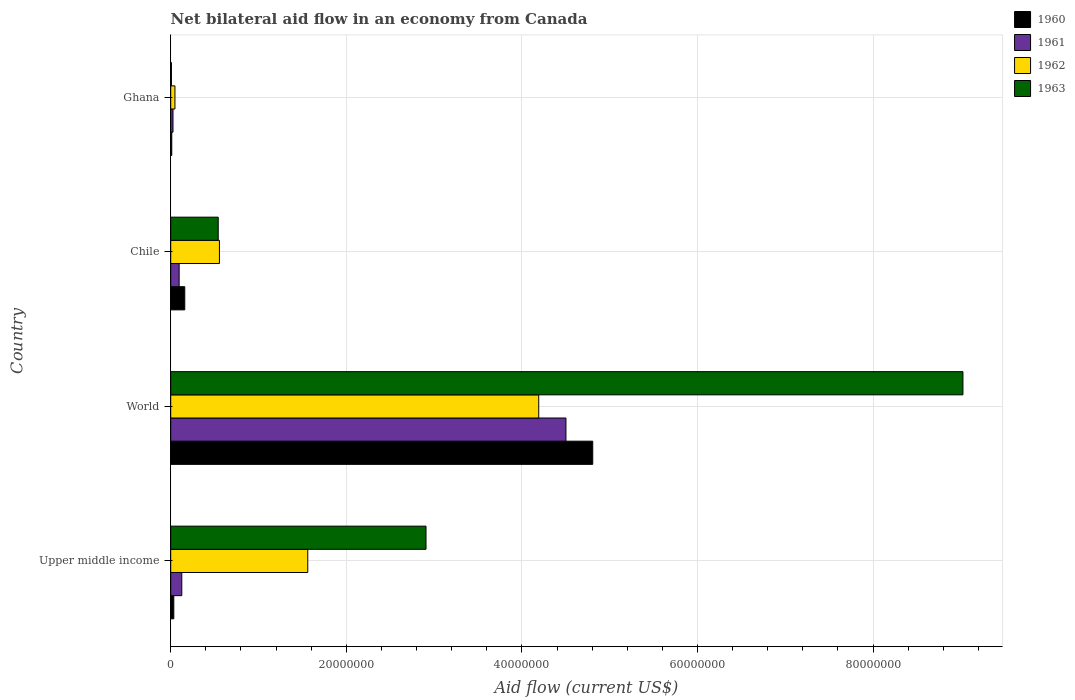How many groups of bars are there?
Provide a short and direct response. 4. How many bars are there on the 2nd tick from the top?
Your answer should be very brief. 4. What is the net bilateral aid flow in 1961 in Upper middle income?
Ensure brevity in your answer.  1.26e+06. Across all countries, what is the maximum net bilateral aid flow in 1961?
Give a very brief answer. 4.50e+07. Across all countries, what is the minimum net bilateral aid flow in 1962?
Offer a very short reply. 4.80e+05. In which country was the net bilateral aid flow in 1962 maximum?
Your response must be concise. World. What is the total net bilateral aid flow in 1962 in the graph?
Keep it short and to the point. 6.36e+07. What is the difference between the net bilateral aid flow in 1960 in Ghana and that in World?
Your answer should be very brief. -4.80e+07. What is the difference between the net bilateral aid flow in 1961 in Chile and the net bilateral aid flow in 1960 in World?
Provide a short and direct response. -4.71e+07. What is the average net bilateral aid flow in 1963 per country?
Ensure brevity in your answer.  3.12e+07. What is the difference between the net bilateral aid flow in 1963 and net bilateral aid flow in 1960 in Upper middle income?
Offer a terse response. 2.87e+07. In how many countries, is the net bilateral aid flow in 1962 greater than 80000000 US$?
Make the answer very short. 0. What is the ratio of the net bilateral aid flow in 1961 in Ghana to that in World?
Give a very brief answer. 0.01. Is the difference between the net bilateral aid flow in 1963 in Ghana and World greater than the difference between the net bilateral aid flow in 1960 in Ghana and World?
Provide a short and direct response. No. What is the difference between the highest and the second highest net bilateral aid flow in 1960?
Offer a terse response. 4.65e+07. What is the difference between the highest and the lowest net bilateral aid flow in 1960?
Keep it short and to the point. 4.80e+07. In how many countries, is the net bilateral aid flow in 1960 greater than the average net bilateral aid flow in 1960 taken over all countries?
Provide a succinct answer. 1. Is it the case that in every country, the sum of the net bilateral aid flow in 1962 and net bilateral aid flow in 1960 is greater than the sum of net bilateral aid flow in 1961 and net bilateral aid flow in 1963?
Provide a short and direct response. No. What does the 2nd bar from the bottom in Chile represents?
Keep it short and to the point. 1961. How many bars are there?
Provide a short and direct response. 16. Are all the bars in the graph horizontal?
Keep it short and to the point. Yes. How many countries are there in the graph?
Your answer should be compact. 4. Are the values on the major ticks of X-axis written in scientific E-notation?
Provide a succinct answer. No. Does the graph contain grids?
Offer a very short reply. Yes. Where does the legend appear in the graph?
Offer a very short reply. Top right. How are the legend labels stacked?
Your answer should be compact. Vertical. What is the title of the graph?
Provide a short and direct response. Net bilateral aid flow in an economy from Canada. Does "1987" appear as one of the legend labels in the graph?
Provide a succinct answer. No. What is the label or title of the X-axis?
Offer a very short reply. Aid flow (current US$). What is the label or title of the Y-axis?
Offer a terse response. Country. What is the Aid flow (current US$) in 1961 in Upper middle income?
Your response must be concise. 1.26e+06. What is the Aid flow (current US$) in 1962 in Upper middle income?
Make the answer very short. 1.56e+07. What is the Aid flow (current US$) of 1963 in Upper middle income?
Provide a succinct answer. 2.91e+07. What is the Aid flow (current US$) of 1960 in World?
Your answer should be compact. 4.81e+07. What is the Aid flow (current US$) of 1961 in World?
Give a very brief answer. 4.50e+07. What is the Aid flow (current US$) of 1962 in World?
Provide a short and direct response. 4.19e+07. What is the Aid flow (current US$) of 1963 in World?
Provide a succinct answer. 9.02e+07. What is the Aid flow (current US$) of 1960 in Chile?
Give a very brief answer. 1.60e+06. What is the Aid flow (current US$) of 1961 in Chile?
Offer a terse response. 9.60e+05. What is the Aid flow (current US$) of 1962 in Chile?
Offer a terse response. 5.55e+06. What is the Aid flow (current US$) of 1963 in Chile?
Offer a very short reply. 5.41e+06. What is the Aid flow (current US$) of 1962 in Ghana?
Make the answer very short. 4.80e+05. What is the Aid flow (current US$) of 1963 in Ghana?
Give a very brief answer. 8.00e+04. Across all countries, what is the maximum Aid flow (current US$) of 1960?
Your answer should be very brief. 4.81e+07. Across all countries, what is the maximum Aid flow (current US$) of 1961?
Offer a very short reply. 4.50e+07. Across all countries, what is the maximum Aid flow (current US$) in 1962?
Your response must be concise. 4.19e+07. Across all countries, what is the maximum Aid flow (current US$) in 1963?
Your response must be concise. 9.02e+07. Across all countries, what is the minimum Aid flow (current US$) of 1961?
Your answer should be very brief. 2.60e+05. Across all countries, what is the minimum Aid flow (current US$) in 1962?
Give a very brief answer. 4.80e+05. Across all countries, what is the minimum Aid flow (current US$) of 1963?
Make the answer very short. 8.00e+04. What is the total Aid flow (current US$) of 1960 in the graph?
Make the answer very short. 5.01e+07. What is the total Aid flow (current US$) of 1961 in the graph?
Keep it short and to the point. 4.75e+07. What is the total Aid flow (current US$) of 1962 in the graph?
Your answer should be very brief. 6.36e+07. What is the total Aid flow (current US$) of 1963 in the graph?
Offer a terse response. 1.25e+08. What is the difference between the Aid flow (current US$) of 1960 in Upper middle income and that in World?
Your answer should be compact. -4.77e+07. What is the difference between the Aid flow (current US$) of 1961 in Upper middle income and that in World?
Your answer should be very brief. -4.38e+07. What is the difference between the Aid flow (current US$) in 1962 in Upper middle income and that in World?
Ensure brevity in your answer.  -2.63e+07. What is the difference between the Aid flow (current US$) in 1963 in Upper middle income and that in World?
Make the answer very short. -6.12e+07. What is the difference between the Aid flow (current US$) in 1960 in Upper middle income and that in Chile?
Your answer should be compact. -1.25e+06. What is the difference between the Aid flow (current US$) of 1961 in Upper middle income and that in Chile?
Provide a succinct answer. 3.00e+05. What is the difference between the Aid flow (current US$) of 1962 in Upper middle income and that in Chile?
Ensure brevity in your answer.  1.01e+07. What is the difference between the Aid flow (current US$) in 1963 in Upper middle income and that in Chile?
Your answer should be compact. 2.37e+07. What is the difference between the Aid flow (current US$) in 1960 in Upper middle income and that in Ghana?
Offer a terse response. 2.30e+05. What is the difference between the Aid flow (current US$) of 1962 in Upper middle income and that in Ghana?
Keep it short and to the point. 1.51e+07. What is the difference between the Aid flow (current US$) in 1963 in Upper middle income and that in Ghana?
Make the answer very short. 2.90e+07. What is the difference between the Aid flow (current US$) in 1960 in World and that in Chile?
Your answer should be very brief. 4.65e+07. What is the difference between the Aid flow (current US$) in 1961 in World and that in Chile?
Keep it short and to the point. 4.41e+07. What is the difference between the Aid flow (current US$) in 1962 in World and that in Chile?
Keep it short and to the point. 3.64e+07. What is the difference between the Aid flow (current US$) of 1963 in World and that in Chile?
Offer a very short reply. 8.48e+07. What is the difference between the Aid flow (current US$) of 1960 in World and that in Ghana?
Keep it short and to the point. 4.80e+07. What is the difference between the Aid flow (current US$) in 1961 in World and that in Ghana?
Keep it short and to the point. 4.48e+07. What is the difference between the Aid flow (current US$) in 1962 in World and that in Ghana?
Keep it short and to the point. 4.14e+07. What is the difference between the Aid flow (current US$) of 1963 in World and that in Ghana?
Give a very brief answer. 9.02e+07. What is the difference between the Aid flow (current US$) in 1960 in Chile and that in Ghana?
Your answer should be very brief. 1.48e+06. What is the difference between the Aid flow (current US$) in 1962 in Chile and that in Ghana?
Your response must be concise. 5.07e+06. What is the difference between the Aid flow (current US$) in 1963 in Chile and that in Ghana?
Provide a short and direct response. 5.33e+06. What is the difference between the Aid flow (current US$) of 1960 in Upper middle income and the Aid flow (current US$) of 1961 in World?
Provide a short and direct response. -4.47e+07. What is the difference between the Aid flow (current US$) in 1960 in Upper middle income and the Aid flow (current US$) in 1962 in World?
Your answer should be compact. -4.16e+07. What is the difference between the Aid flow (current US$) of 1960 in Upper middle income and the Aid flow (current US$) of 1963 in World?
Your response must be concise. -8.99e+07. What is the difference between the Aid flow (current US$) of 1961 in Upper middle income and the Aid flow (current US$) of 1962 in World?
Your answer should be compact. -4.07e+07. What is the difference between the Aid flow (current US$) of 1961 in Upper middle income and the Aid flow (current US$) of 1963 in World?
Offer a very short reply. -8.90e+07. What is the difference between the Aid flow (current US$) of 1962 in Upper middle income and the Aid flow (current US$) of 1963 in World?
Make the answer very short. -7.46e+07. What is the difference between the Aid flow (current US$) in 1960 in Upper middle income and the Aid flow (current US$) in 1961 in Chile?
Give a very brief answer. -6.10e+05. What is the difference between the Aid flow (current US$) of 1960 in Upper middle income and the Aid flow (current US$) of 1962 in Chile?
Make the answer very short. -5.20e+06. What is the difference between the Aid flow (current US$) of 1960 in Upper middle income and the Aid flow (current US$) of 1963 in Chile?
Offer a terse response. -5.06e+06. What is the difference between the Aid flow (current US$) of 1961 in Upper middle income and the Aid flow (current US$) of 1962 in Chile?
Offer a very short reply. -4.29e+06. What is the difference between the Aid flow (current US$) of 1961 in Upper middle income and the Aid flow (current US$) of 1963 in Chile?
Provide a short and direct response. -4.15e+06. What is the difference between the Aid flow (current US$) of 1962 in Upper middle income and the Aid flow (current US$) of 1963 in Chile?
Offer a terse response. 1.02e+07. What is the difference between the Aid flow (current US$) in 1960 in Upper middle income and the Aid flow (current US$) in 1961 in Ghana?
Make the answer very short. 9.00e+04. What is the difference between the Aid flow (current US$) of 1960 in Upper middle income and the Aid flow (current US$) of 1962 in Ghana?
Your answer should be compact. -1.30e+05. What is the difference between the Aid flow (current US$) in 1960 in Upper middle income and the Aid flow (current US$) in 1963 in Ghana?
Your answer should be compact. 2.70e+05. What is the difference between the Aid flow (current US$) of 1961 in Upper middle income and the Aid flow (current US$) of 1962 in Ghana?
Provide a short and direct response. 7.80e+05. What is the difference between the Aid flow (current US$) in 1961 in Upper middle income and the Aid flow (current US$) in 1963 in Ghana?
Ensure brevity in your answer.  1.18e+06. What is the difference between the Aid flow (current US$) of 1962 in Upper middle income and the Aid flow (current US$) of 1963 in Ghana?
Ensure brevity in your answer.  1.55e+07. What is the difference between the Aid flow (current US$) of 1960 in World and the Aid flow (current US$) of 1961 in Chile?
Provide a short and direct response. 4.71e+07. What is the difference between the Aid flow (current US$) of 1960 in World and the Aid flow (current US$) of 1962 in Chile?
Your response must be concise. 4.25e+07. What is the difference between the Aid flow (current US$) in 1960 in World and the Aid flow (current US$) in 1963 in Chile?
Make the answer very short. 4.27e+07. What is the difference between the Aid flow (current US$) of 1961 in World and the Aid flow (current US$) of 1962 in Chile?
Make the answer very short. 3.95e+07. What is the difference between the Aid flow (current US$) of 1961 in World and the Aid flow (current US$) of 1963 in Chile?
Provide a short and direct response. 3.96e+07. What is the difference between the Aid flow (current US$) in 1962 in World and the Aid flow (current US$) in 1963 in Chile?
Your answer should be very brief. 3.65e+07. What is the difference between the Aid flow (current US$) of 1960 in World and the Aid flow (current US$) of 1961 in Ghana?
Your response must be concise. 4.78e+07. What is the difference between the Aid flow (current US$) in 1960 in World and the Aid flow (current US$) in 1962 in Ghana?
Offer a terse response. 4.76e+07. What is the difference between the Aid flow (current US$) of 1960 in World and the Aid flow (current US$) of 1963 in Ghana?
Ensure brevity in your answer.  4.80e+07. What is the difference between the Aid flow (current US$) of 1961 in World and the Aid flow (current US$) of 1962 in Ghana?
Your answer should be compact. 4.45e+07. What is the difference between the Aid flow (current US$) of 1961 in World and the Aid flow (current US$) of 1963 in Ghana?
Provide a succinct answer. 4.49e+07. What is the difference between the Aid flow (current US$) in 1962 in World and the Aid flow (current US$) in 1963 in Ghana?
Your answer should be very brief. 4.18e+07. What is the difference between the Aid flow (current US$) in 1960 in Chile and the Aid flow (current US$) in 1961 in Ghana?
Offer a terse response. 1.34e+06. What is the difference between the Aid flow (current US$) of 1960 in Chile and the Aid flow (current US$) of 1962 in Ghana?
Offer a very short reply. 1.12e+06. What is the difference between the Aid flow (current US$) in 1960 in Chile and the Aid flow (current US$) in 1963 in Ghana?
Offer a very short reply. 1.52e+06. What is the difference between the Aid flow (current US$) of 1961 in Chile and the Aid flow (current US$) of 1963 in Ghana?
Keep it short and to the point. 8.80e+05. What is the difference between the Aid flow (current US$) of 1962 in Chile and the Aid flow (current US$) of 1963 in Ghana?
Keep it short and to the point. 5.47e+06. What is the average Aid flow (current US$) in 1960 per country?
Provide a succinct answer. 1.25e+07. What is the average Aid flow (current US$) of 1961 per country?
Your answer should be very brief. 1.19e+07. What is the average Aid flow (current US$) in 1962 per country?
Your response must be concise. 1.59e+07. What is the average Aid flow (current US$) of 1963 per country?
Keep it short and to the point. 3.12e+07. What is the difference between the Aid flow (current US$) in 1960 and Aid flow (current US$) in 1961 in Upper middle income?
Ensure brevity in your answer.  -9.10e+05. What is the difference between the Aid flow (current US$) in 1960 and Aid flow (current US$) in 1962 in Upper middle income?
Provide a short and direct response. -1.53e+07. What is the difference between the Aid flow (current US$) in 1960 and Aid flow (current US$) in 1963 in Upper middle income?
Offer a very short reply. -2.87e+07. What is the difference between the Aid flow (current US$) of 1961 and Aid flow (current US$) of 1962 in Upper middle income?
Keep it short and to the point. -1.44e+07. What is the difference between the Aid flow (current US$) in 1961 and Aid flow (current US$) in 1963 in Upper middle income?
Your answer should be very brief. -2.78e+07. What is the difference between the Aid flow (current US$) in 1962 and Aid flow (current US$) in 1963 in Upper middle income?
Give a very brief answer. -1.35e+07. What is the difference between the Aid flow (current US$) of 1960 and Aid flow (current US$) of 1961 in World?
Give a very brief answer. 3.05e+06. What is the difference between the Aid flow (current US$) of 1960 and Aid flow (current US$) of 1962 in World?
Your answer should be very brief. 6.15e+06. What is the difference between the Aid flow (current US$) in 1960 and Aid flow (current US$) in 1963 in World?
Offer a very short reply. -4.22e+07. What is the difference between the Aid flow (current US$) in 1961 and Aid flow (current US$) in 1962 in World?
Keep it short and to the point. 3.10e+06. What is the difference between the Aid flow (current US$) of 1961 and Aid flow (current US$) of 1963 in World?
Ensure brevity in your answer.  -4.52e+07. What is the difference between the Aid flow (current US$) in 1962 and Aid flow (current US$) in 1963 in World?
Provide a succinct answer. -4.83e+07. What is the difference between the Aid flow (current US$) in 1960 and Aid flow (current US$) in 1961 in Chile?
Your answer should be very brief. 6.40e+05. What is the difference between the Aid flow (current US$) in 1960 and Aid flow (current US$) in 1962 in Chile?
Offer a very short reply. -3.95e+06. What is the difference between the Aid flow (current US$) of 1960 and Aid flow (current US$) of 1963 in Chile?
Offer a very short reply. -3.81e+06. What is the difference between the Aid flow (current US$) of 1961 and Aid flow (current US$) of 1962 in Chile?
Provide a short and direct response. -4.59e+06. What is the difference between the Aid flow (current US$) of 1961 and Aid flow (current US$) of 1963 in Chile?
Your answer should be very brief. -4.45e+06. What is the difference between the Aid flow (current US$) in 1960 and Aid flow (current US$) in 1961 in Ghana?
Offer a very short reply. -1.40e+05. What is the difference between the Aid flow (current US$) of 1960 and Aid flow (current US$) of 1962 in Ghana?
Your answer should be compact. -3.60e+05. What is the difference between the Aid flow (current US$) in 1961 and Aid flow (current US$) in 1962 in Ghana?
Offer a terse response. -2.20e+05. What is the difference between the Aid flow (current US$) of 1961 and Aid flow (current US$) of 1963 in Ghana?
Provide a succinct answer. 1.80e+05. What is the difference between the Aid flow (current US$) of 1962 and Aid flow (current US$) of 1963 in Ghana?
Offer a very short reply. 4.00e+05. What is the ratio of the Aid flow (current US$) of 1960 in Upper middle income to that in World?
Make the answer very short. 0.01. What is the ratio of the Aid flow (current US$) in 1961 in Upper middle income to that in World?
Make the answer very short. 0.03. What is the ratio of the Aid flow (current US$) in 1962 in Upper middle income to that in World?
Ensure brevity in your answer.  0.37. What is the ratio of the Aid flow (current US$) of 1963 in Upper middle income to that in World?
Offer a terse response. 0.32. What is the ratio of the Aid flow (current US$) in 1960 in Upper middle income to that in Chile?
Give a very brief answer. 0.22. What is the ratio of the Aid flow (current US$) of 1961 in Upper middle income to that in Chile?
Make the answer very short. 1.31. What is the ratio of the Aid flow (current US$) of 1962 in Upper middle income to that in Chile?
Make the answer very short. 2.81. What is the ratio of the Aid flow (current US$) of 1963 in Upper middle income to that in Chile?
Offer a very short reply. 5.38. What is the ratio of the Aid flow (current US$) of 1960 in Upper middle income to that in Ghana?
Keep it short and to the point. 2.92. What is the ratio of the Aid flow (current US$) in 1961 in Upper middle income to that in Ghana?
Provide a succinct answer. 4.85. What is the ratio of the Aid flow (current US$) of 1962 in Upper middle income to that in Ghana?
Offer a very short reply. 32.52. What is the ratio of the Aid flow (current US$) of 1963 in Upper middle income to that in Ghana?
Keep it short and to the point. 363.5. What is the ratio of the Aid flow (current US$) in 1960 in World to that in Chile?
Offer a very short reply. 30.04. What is the ratio of the Aid flow (current US$) of 1961 in World to that in Chile?
Give a very brief answer. 46.9. What is the ratio of the Aid flow (current US$) in 1962 in World to that in Chile?
Your answer should be compact. 7.55. What is the ratio of the Aid flow (current US$) of 1963 in World to that in Chile?
Your answer should be very brief. 16.68. What is the ratio of the Aid flow (current US$) of 1960 in World to that in Ghana?
Your response must be concise. 400.58. What is the ratio of the Aid flow (current US$) of 1961 in World to that in Ghana?
Provide a short and direct response. 173.15. What is the ratio of the Aid flow (current US$) of 1962 in World to that in Ghana?
Provide a short and direct response. 87.33. What is the ratio of the Aid flow (current US$) in 1963 in World to that in Ghana?
Offer a terse response. 1128. What is the ratio of the Aid flow (current US$) of 1960 in Chile to that in Ghana?
Your answer should be compact. 13.33. What is the ratio of the Aid flow (current US$) in 1961 in Chile to that in Ghana?
Ensure brevity in your answer.  3.69. What is the ratio of the Aid flow (current US$) of 1962 in Chile to that in Ghana?
Offer a very short reply. 11.56. What is the ratio of the Aid flow (current US$) in 1963 in Chile to that in Ghana?
Give a very brief answer. 67.62. What is the difference between the highest and the second highest Aid flow (current US$) of 1960?
Ensure brevity in your answer.  4.65e+07. What is the difference between the highest and the second highest Aid flow (current US$) in 1961?
Provide a succinct answer. 4.38e+07. What is the difference between the highest and the second highest Aid flow (current US$) of 1962?
Offer a very short reply. 2.63e+07. What is the difference between the highest and the second highest Aid flow (current US$) in 1963?
Your answer should be very brief. 6.12e+07. What is the difference between the highest and the lowest Aid flow (current US$) of 1960?
Keep it short and to the point. 4.80e+07. What is the difference between the highest and the lowest Aid flow (current US$) in 1961?
Your response must be concise. 4.48e+07. What is the difference between the highest and the lowest Aid flow (current US$) in 1962?
Offer a terse response. 4.14e+07. What is the difference between the highest and the lowest Aid flow (current US$) of 1963?
Offer a terse response. 9.02e+07. 